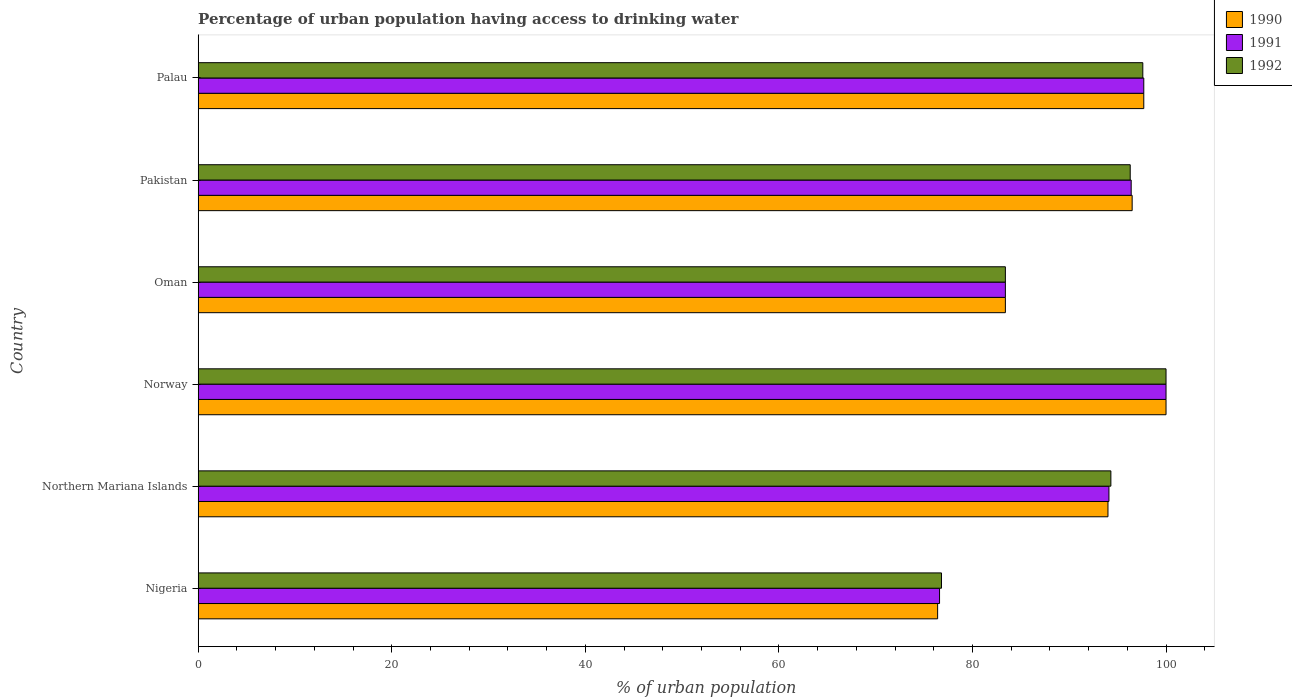How many different coloured bars are there?
Offer a very short reply. 3. How many groups of bars are there?
Offer a terse response. 6. How many bars are there on the 1st tick from the top?
Your answer should be very brief. 3. How many bars are there on the 1st tick from the bottom?
Provide a short and direct response. 3. What is the label of the 6th group of bars from the top?
Offer a very short reply. Nigeria. What is the percentage of urban population having access to drinking water in 1992 in Pakistan?
Offer a very short reply. 96.3. Across all countries, what is the maximum percentage of urban population having access to drinking water in 1992?
Keep it short and to the point. 100. Across all countries, what is the minimum percentage of urban population having access to drinking water in 1990?
Provide a succinct answer. 76.4. In which country was the percentage of urban population having access to drinking water in 1990 minimum?
Offer a terse response. Nigeria. What is the total percentage of urban population having access to drinking water in 1991 in the graph?
Your answer should be compact. 548.2. What is the difference between the percentage of urban population having access to drinking water in 1991 in Northern Mariana Islands and that in Palau?
Offer a terse response. -3.6. What is the difference between the percentage of urban population having access to drinking water in 1992 in Oman and the percentage of urban population having access to drinking water in 1991 in Nigeria?
Offer a very short reply. 6.8. What is the average percentage of urban population having access to drinking water in 1990 per country?
Your response must be concise. 91.33. What is the difference between the percentage of urban population having access to drinking water in 1990 and percentage of urban population having access to drinking water in 1991 in Northern Mariana Islands?
Ensure brevity in your answer.  -0.1. What is the ratio of the percentage of urban population having access to drinking water in 1990 in Northern Mariana Islands to that in Pakistan?
Your answer should be compact. 0.97. Is the percentage of urban population having access to drinking water in 1992 in Pakistan less than that in Palau?
Ensure brevity in your answer.  Yes. Is the difference between the percentage of urban population having access to drinking water in 1990 in Oman and Palau greater than the difference between the percentage of urban population having access to drinking water in 1991 in Oman and Palau?
Offer a terse response. No. What is the difference between the highest and the second highest percentage of urban population having access to drinking water in 1992?
Ensure brevity in your answer.  2.4. What is the difference between the highest and the lowest percentage of urban population having access to drinking water in 1992?
Make the answer very short. 23.2. In how many countries, is the percentage of urban population having access to drinking water in 1990 greater than the average percentage of urban population having access to drinking water in 1990 taken over all countries?
Provide a succinct answer. 4. What does the 1st bar from the top in Northern Mariana Islands represents?
Ensure brevity in your answer.  1992. What does the 1st bar from the bottom in Northern Mariana Islands represents?
Ensure brevity in your answer.  1990. Is it the case that in every country, the sum of the percentage of urban population having access to drinking water in 1990 and percentage of urban population having access to drinking water in 1991 is greater than the percentage of urban population having access to drinking water in 1992?
Offer a terse response. Yes. How many countries are there in the graph?
Make the answer very short. 6. Are the values on the major ticks of X-axis written in scientific E-notation?
Your response must be concise. No. Does the graph contain grids?
Ensure brevity in your answer.  No. How many legend labels are there?
Provide a short and direct response. 3. What is the title of the graph?
Offer a very short reply. Percentage of urban population having access to drinking water. What is the label or title of the X-axis?
Your answer should be compact. % of urban population. What is the label or title of the Y-axis?
Your answer should be compact. Country. What is the % of urban population of 1990 in Nigeria?
Give a very brief answer. 76.4. What is the % of urban population in 1991 in Nigeria?
Your answer should be very brief. 76.6. What is the % of urban population of 1992 in Nigeria?
Give a very brief answer. 76.8. What is the % of urban population in 1990 in Northern Mariana Islands?
Provide a short and direct response. 94. What is the % of urban population of 1991 in Northern Mariana Islands?
Offer a very short reply. 94.1. What is the % of urban population in 1992 in Northern Mariana Islands?
Keep it short and to the point. 94.3. What is the % of urban population in 1991 in Norway?
Provide a succinct answer. 100. What is the % of urban population in 1990 in Oman?
Your answer should be compact. 83.4. What is the % of urban population of 1991 in Oman?
Give a very brief answer. 83.4. What is the % of urban population of 1992 in Oman?
Your response must be concise. 83.4. What is the % of urban population of 1990 in Pakistan?
Provide a short and direct response. 96.5. What is the % of urban population of 1991 in Pakistan?
Give a very brief answer. 96.4. What is the % of urban population in 1992 in Pakistan?
Provide a short and direct response. 96.3. What is the % of urban population in 1990 in Palau?
Provide a short and direct response. 97.7. What is the % of urban population in 1991 in Palau?
Give a very brief answer. 97.7. What is the % of urban population of 1992 in Palau?
Offer a very short reply. 97.6. Across all countries, what is the maximum % of urban population in 1990?
Provide a short and direct response. 100. Across all countries, what is the maximum % of urban population of 1992?
Your answer should be very brief. 100. Across all countries, what is the minimum % of urban population of 1990?
Provide a short and direct response. 76.4. Across all countries, what is the minimum % of urban population in 1991?
Offer a very short reply. 76.6. Across all countries, what is the minimum % of urban population in 1992?
Make the answer very short. 76.8. What is the total % of urban population of 1990 in the graph?
Your answer should be compact. 548. What is the total % of urban population in 1991 in the graph?
Provide a succinct answer. 548.2. What is the total % of urban population in 1992 in the graph?
Keep it short and to the point. 548.4. What is the difference between the % of urban population in 1990 in Nigeria and that in Northern Mariana Islands?
Offer a very short reply. -17.6. What is the difference between the % of urban population in 1991 in Nigeria and that in Northern Mariana Islands?
Keep it short and to the point. -17.5. What is the difference between the % of urban population of 1992 in Nigeria and that in Northern Mariana Islands?
Your answer should be compact. -17.5. What is the difference between the % of urban population of 1990 in Nigeria and that in Norway?
Offer a very short reply. -23.6. What is the difference between the % of urban population of 1991 in Nigeria and that in Norway?
Keep it short and to the point. -23.4. What is the difference between the % of urban population in 1992 in Nigeria and that in Norway?
Keep it short and to the point. -23.2. What is the difference between the % of urban population in 1990 in Nigeria and that in Oman?
Make the answer very short. -7. What is the difference between the % of urban population of 1992 in Nigeria and that in Oman?
Your response must be concise. -6.6. What is the difference between the % of urban population of 1990 in Nigeria and that in Pakistan?
Make the answer very short. -20.1. What is the difference between the % of urban population in 1991 in Nigeria and that in Pakistan?
Ensure brevity in your answer.  -19.8. What is the difference between the % of urban population of 1992 in Nigeria and that in Pakistan?
Ensure brevity in your answer.  -19.5. What is the difference between the % of urban population in 1990 in Nigeria and that in Palau?
Ensure brevity in your answer.  -21.3. What is the difference between the % of urban population of 1991 in Nigeria and that in Palau?
Give a very brief answer. -21.1. What is the difference between the % of urban population in 1992 in Nigeria and that in Palau?
Make the answer very short. -20.8. What is the difference between the % of urban population in 1990 in Northern Mariana Islands and that in Norway?
Keep it short and to the point. -6. What is the difference between the % of urban population in 1991 in Northern Mariana Islands and that in Norway?
Ensure brevity in your answer.  -5.9. What is the difference between the % of urban population of 1992 in Northern Mariana Islands and that in Norway?
Keep it short and to the point. -5.7. What is the difference between the % of urban population of 1992 in Northern Mariana Islands and that in Oman?
Provide a succinct answer. 10.9. What is the difference between the % of urban population of 1990 in Northern Mariana Islands and that in Pakistan?
Ensure brevity in your answer.  -2.5. What is the difference between the % of urban population in 1991 in Northern Mariana Islands and that in Pakistan?
Provide a short and direct response. -2.3. What is the difference between the % of urban population in 1992 in Northern Mariana Islands and that in Pakistan?
Make the answer very short. -2. What is the difference between the % of urban population of 1990 in Northern Mariana Islands and that in Palau?
Ensure brevity in your answer.  -3.7. What is the difference between the % of urban population of 1990 in Norway and that in Oman?
Provide a succinct answer. 16.6. What is the difference between the % of urban population in 1991 in Norway and that in Pakistan?
Ensure brevity in your answer.  3.6. What is the difference between the % of urban population in 1992 in Norway and that in Pakistan?
Offer a very short reply. 3.7. What is the difference between the % of urban population of 1991 in Norway and that in Palau?
Your answer should be very brief. 2.3. What is the difference between the % of urban population in 1991 in Oman and that in Pakistan?
Provide a succinct answer. -13. What is the difference between the % of urban population in 1992 in Oman and that in Pakistan?
Give a very brief answer. -12.9. What is the difference between the % of urban population of 1990 in Oman and that in Palau?
Provide a short and direct response. -14.3. What is the difference between the % of urban population in 1991 in Oman and that in Palau?
Your answer should be compact. -14.3. What is the difference between the % of urban population of 1990 in Pakistan and that in Palau?
Make the answer very short. -1.2. What is the difference between the % of urban population of 1991 in Pakistan and that in Palau?
Give a very brief answer. -1.3. What is the difference between the % of urban population of 1990 in Nigeria and the % of urban population of 1991 in Northern Mariana Islands?
Your answer should be very brief. -17.7. What is the difference between the % of urban population in 1990 in Nigeria and the % of urban population in 1992 in Northern Mariana Islands?
Keep it short and to the point. -17.9. What is the difference between the % of urban population of 1991 in Nigeria and the % of urban population of 1992 in Northern Mariana Islands?
Offer a terse response. -17.7. What is the difference between the % of urban population in 1990 in Nigeria and the % of urban population in 1991 in Norway?
Make the answer very short. -23.6. What is the difference between the % of urban population of 1990 in Nigeria and the % of urban population of 1992 in Norway?
Provide a short and direct response. -23.6. What is the difference between the % of urban population in 1991 in Nigeria and the % of urban population in 1992 in Norway?
Ensure brevity in your answer.  -23.4. What is the difference between the % of urban population of 1990 in Nigeria and the % of urban population of 1991 in Oman?
Provide a succinct answer. -7. What is the difference between the % of urban population in 1990 in Nigeria and the % of urban population in 1992 in Oman?
Give a very brief answer. -7. What is the difference between the % of urban population of 1990 in Nigeria and the % of urban population of 1992 in Pakistan?
Your answer should be compact. -19.9. What is the difference between the % of urban population in 1991 in Nigeria and the % of urban population in 1992 in Pakistan?
Your answer should be compact. -19.7. What is the difference between the % of urban population in 1990 in Nigeria and the % of urban population in 1991 in Palau?
Provide a short and direct response. -21.3. What is the difference between the % of urban population of 1990 in Nigeria and the % of urban population of 1992 in Palau?
Your answer should be compact. -21.2. What is the difference between the % of urban population of 1991 in Nigeria and the % of urban population of 1992 in Palau?
Offer a terse response. -21. What is the difference between the % of urban population of 1990 in Northern Mariana Islands and the % of urban population of 1991 in Norway?
Your answer should be very brief. -6. What is the difference between the % of urban population of 1990 in Northern Mariana Islands and the % of urban population of 1992 in Norway?
Provide a succinct answer. -6. What is the difference between the % of urban population of 1991 in Northern Mariana Islands and the % of urban population of 1992 in Norway?
Keep it short and to the point. -5.9. What is the difference between the % of urban population of 1990 in Northern Mariana Islands and the % of urban population of 1991 in Oman?
Offer a very short reply. 10.6. What is the difference between the % of urban population in 1990 in Northern Mariana Islands and the % of urban population in 1992 in Oman?
Make the answer very short. 10.6. What is the difference between the % of urban population of 1990 in Northern Mariana Islands and the % of urban population of 1992 in Pakistan?
Offer a terse response. -2.3. What is the difference between the % of urban population in 1990 in Northern Mariana Islands and the % of urban population in 1991 in Palau?
Offer a terse response. -3.7. What is the difference between the % of urban population of 1990 in Northern Mariana Islands and the % of urban population of 1992 in Palau?
Your response must be concise. -3.6. What is the difference between the % of urban population of 1990 in Norway and the % of urban population of 1992 in Oman?
Make the answer very short. 16.6. What is the difference between the % of urban population in 1990 in Norway and the % of urban population in 1991 in Pakistan?
Provide a short and direct response. 3.6. What is the difference between the % of urban population in 1990 in Norway and the % of urban population in 1992 in Pakistan?
Ensure brevity in your answer.  3.7. What is the difference between the % of urban population of 1990 in Norway and the % of urban population of 1992 in Palau?
Offer a terse response. 2.4. What is the difference between the % of urban population in 1991 in Oman and the % of urban population in 1992 in Pakistan?
Keep it short and to the point. -12.9. What is the difference between the % of urban population in 1990 in Oman and the % of urban population in 1991 in Palau?
Keep it short and to the point. -14.3. What is the difference between the % of urban population in 1990 in Oman and the % of urban population in 1992 in Palau?
Keep it short and to the point. -14.2. What is the difference between the % of urban population in 1991 in Oman and the % of urban population in 1992 in Palau?
Provide a succinct answer. -14.2. What is the difference between the % of urban population in 1990 in Pakistan and the % of urban population in 1991 in Palau?
Your answer should be very brief. -1.2. What is the difference between the % of urban population of 1990 in Pakistan and the % of urban population of 1992 in Palau?
Provide a succinct answer. -1.1. What is the difference between the % of urban population of 1991 in Pakistan and the % of urban population of 1992 in Palau?
Give a very brief answer. -1.2. What is the average % of urban population in 1990 per country?
Your answer should be compact. 91.33. What is the average % of urban population of 1991 per country?
Your answer should be very brief. 91.37. What is the average % of urban population in 1992 per country?
Provide a short and direct response. 91.4. What is the difference between the % of urban population of 1990 and % of urban population of 1992 in Nigeria?
Make the answer very short. -0.4. What is the difference between the % of urban population of 1991 and % of urban population of 1992 in Nigeria?
Offer a very short reply. -0.2. What is the difference between the % of urban population of 1990 and % of urban population of 1991 in Northern Mariana Islands?
Provide a succinct answer. -0.1. What is the difference between the % of urban population in 1990 and % of urban population in 1992 in Northern Mariana Islands?
Keep it short and to the point. -0.3. What is the difference between the % of urban population of 1991 and % of urban population of 1992 in Northern Mariana Islands?
Keep it short and to the point. -0.2. What is the difference between the % of urban population of 1990 and % of urban population of 1991 in Norway?
Ensure brevity in your answer.  0. What is the difference between the % of urban population of 1990 and % of urban population of 1992 in Norway?
Provide a succinct answer. 0. What is the difference between the % of urban population in 1991 and % of urban population in 1992 in Norway?
Your answer should be compact. 0. What is the difference between the % of urban population in 1991 and % of urban population in 1992 in Oman?
Your answer should be very brief. 0. What is the difference between the % of urban population in 1991 and % of urban population in 1992 in Pakistan?
Give a very brief answer. 0.1. What is the difference between the % of urban population of 1990 and % of urban population of 1991 in Palau?
Keep it short and to the point. 0. What is the difference between the % of urban population in 1990 and % of urban population in 1992 in Palau?
Make the answer very short. 0.1. What is the difference between the % of urban population in 1991 and % of urban population in 1992 in Palau?
Offer a terse response. 0.1. What is the ratio of the % of urban population of 1990 in Nigeria to that in Northern Mariana Islands?
Provide a short and direct response. 0.81. What is the ratio of the % of urban population in 1991 in Nigeria to that in Northern Mariana Islands?
Provide a succinct answer. 0.81. What is the ratio of the % of urban population of 1992 in Nigeria to that in Northern Mariana Islands?
Make the answer very short. 0.81. What is the ratio of the % of urban population of 1990 in Nigeria to that in Norway?
Your answer should be very brief. 0.76. What is the ratio of the % of urban population of 1991 in Nigeria to that in Norway?
Provide a succinct answer. 0.77. What is the ratio of the % of urban population of 1992 in Nigeria to that in Norway?
Ensure brevity in your answer.  0.77. What is the ratio of the % of urban population in 1990 in Nigeria to that in Oman?
Your answer should be compact. 0.92. What is the ratio of the % of urban population in 1991 in Nigeria to that in Oman?
Provide a succinct answer. 0.92. What is the ratio of the % of urban population of 1992 in Nigeria to that in Oman?
Offer a terse response. 0.92. What is the ratio of the % of urban population in 1990 in Nigeria to that in Pakistan?
Provide a short and direct response. 0.79. What is the ratio of the % of urban population of 1991 in Nigeria to that in Pakistan?
Keep it short and to the point. 0.79. What is the ratio of the % of urban population of 1992 in Nigeria to that in Pakistan?
Your answer should be very brief. 0.8. What is the ratio of the % of urban population of 1990 in Nigeria to that in Palau?
Ensure brevity in your answer.  0.78. What is the ratio of the % of urban population of 1991 in Nigeria to that in Palau?
Provide a short and direct response. 0.78. What is the ratio of the % of urban population in 1992 in Nigeria to that in Palau?
Offer a very short reply. 0.79. What is the ratio of the % of urban population of 1991 in Northern Mariana Islands to that in Norway?
Provide a short and direct response. 0.94. What is the ratio of the % of urban population of 1992 in Northern Mariana Islands to that in Norway?
Keep it short and to the point. 0.94. What is the ratio of the % of urban population of 1990 in Northern Mariana Islands to that in Oman?
Provide a succinct answer. 1.13. What is the ratio of the % of urban population of 1991 in Northern Mariana Islands to that in Oman?
Offer a very short reply. 1.13. What is the ratio of the % of urban population in 1992 in Northern Mariana Islands to that in Oman?
Offer a terse response. 1.13. What is the ratio of the % of urban population of 1990 in Northern Mariana Islands to that in Pakistan?
Make the answer very short. 0.97. What is the ratio of the % of urban population of 1991 in Northern Mariana Islands to that in Pakistan?
Offer a very short reply. 0.98. What is the ratio of the % of urban population of 1992 in Northern Mariana Islands to that in Pakistan?
Give a very brief answer. 0.98. What is the ratio of the % of urban population in 1990 in Northern Mariana Islands to that in Palau?
Your answer should be very brief. 0.96. What is the ratio of the % of urban population in 1991 in Northern Mariana Islands to that in Palau?
Your answer should be compact. 0.96. What is the ratio of the % of urban population in 1992 in Northern Mariana Islands to that in Palau?
Provide a succinct answer. 0.97. What is the ratio of the % of urban population in 1990 in Norway to that in Oman?
Your answer should be compact. 1.2. What is the ratio of the % of urban population of 1991 in Norway to that in Oman?
Your response must be concise. 1.2. What is the ratio of the % of urban population of 1992 in Norway to that in Oman?
Provide a short and direct response. 1.2. What is the ratio of the % of urban population in 1990 in Norway to that in Pakistan?
Provide a short and direct response. 1.04. What is the ratio of the % of urban population in 1991 in Norway to that in Pakistan?
Provide a short and direct response. 1.04. What is the ratio of the % of urban population of 1992 in Norway to that in Pakistan?
Provide a short and direct response. 1.04. What is the ratio of the % of urban population in 1990 in Norway to that in Palau?
Provide a short and direct response. 1.02. What is the ratio of the % of urban population in 1991 in Norway to that in Palau?
Offer a terse response. 1.02. What is the ratio of the % of urban population of 1992 in Norway to that in Palau?
Give a very brief answer. 1.02. What is the ratio of the % of urban population in 1990 in Oman to that in Pakistan?
Your answer should be very brief. 0.86. What is the ratio of the % of urban population of 1991 in Oman to that in Pakistan?
Your answer should be very brief. 0.87. What is the ratio of the % of urban population of 1992 in Oman to that in Pakistan?
Keep it short and to the point. 0.87. What is the ratio of the % of urban population in 1990 in Oman to that in Palau?
Provide a succinct answer. 0.85. What is the ratio of the % of urban population in 1991 in Oman to that in Palau?
Offer a terse response. 0.85. What is the ratio of the % of urban population in 1992 in Oman to that in Palau?
Ensure brevity in your answer.  0.85. What is the ratio of the % of urban population of 1991 in Pakistan to that in Palau?
Keep it short and to the point. 0.99. What is the ratio of the % of urban population in 1992 in Pakistan to that in Palau?
Provide a short and direct response. 0.99. What is the difference between the highest and the second highest % of urban population of 1991?
Offer a terse response. 2.3. What is the difference between the highest and the second highest % of urban population in 1992?
Offer a terse response. 2.4. What is the difference between the highest and the lowest % of urban population in 1990?
Make the answer very short. 23.6. What is the difference between the highest and the lowest % of urban population of 1991?
Your answer should be very brief. 23.4. What is the difference between the highest and the lowest % of urban population of 1992?
Your answer should be very brief. 23.2. 